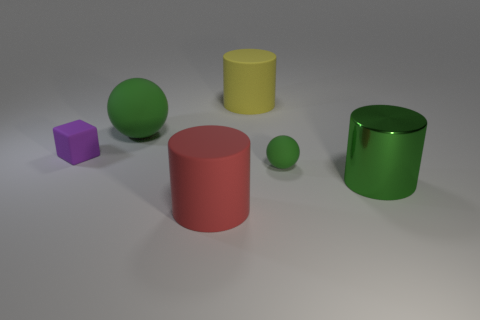There is a big shiny thing that is the same color as the big matte sphere; what is its shape?
Your answer should be very brief. Cylinder. What is the material of the red cylinder to the left of the small rubber object on the right side of the rubber cube?
Your answer should be compact. Rubber. What number of things are either large cylinders or green rubber balls in front of the matte cube?
Provide a succinct answer. 4. The red cylinder that is the same material as the big yellow cylinder is what size?
Ensure brevity in your answer.  Large. Are there more green shiny cylinders behind the matte block than big cylinders?
Your answer should be compact. No. What is the size of the thing that is both behind the tiny purple rubber block and in front of the yellow object?
Offer a very short reply. Large. What is the material of the green thing that is the same shape as the yellow rubber thing?
Your response must be concise. Metal. Are there the same number of green balls and small yellow objects?
Offer a very short reply. No. Does the green matte object that is on the left side of the red cylinder have the same size as the large shiny thing?
Offer a terse response. Yes. The rubber thing that is in front of the big green ball and on the left side of the large red matte object is what color?
Provide a succinct answer. Purple. 